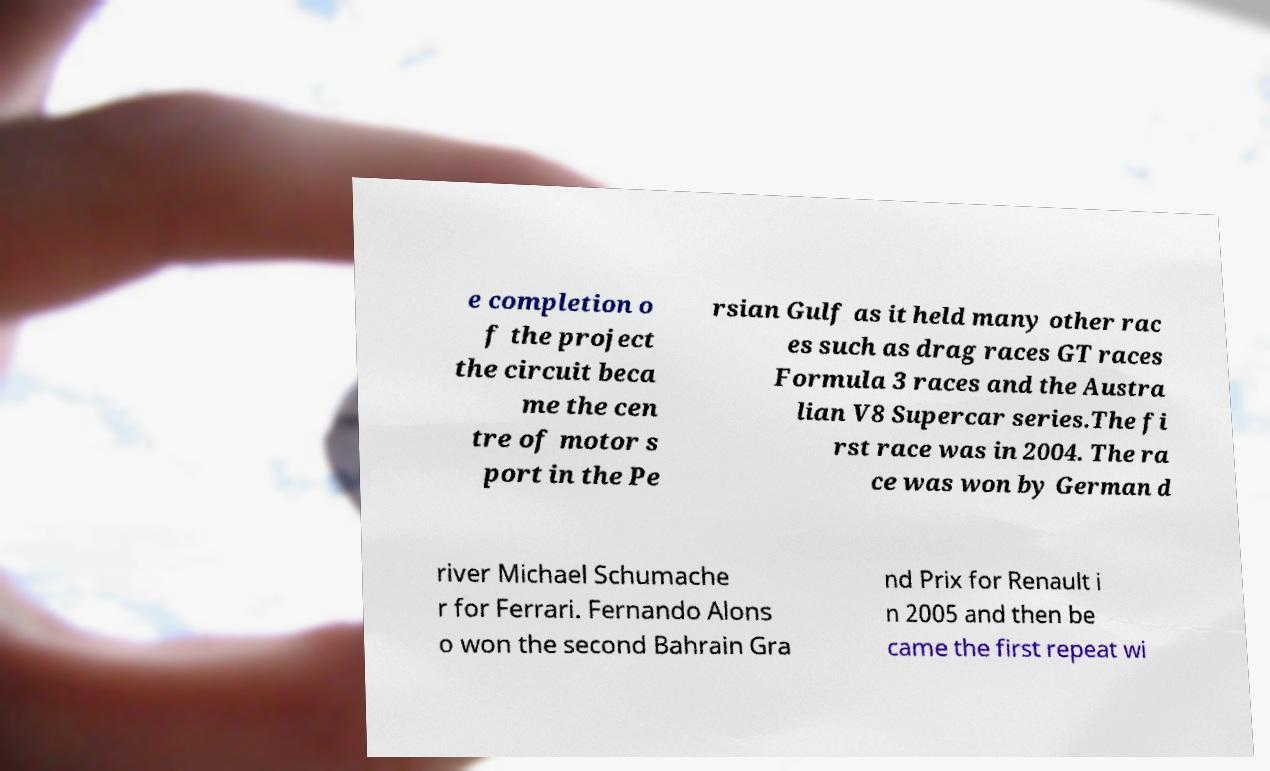Could you extract and type out the text from this image? e completion o f the project the circuit beca me the cen tre of motor s port in the Pe rsian Gulf as it held many other rac es such as drag races GT races Formula 3 races and the Austra lian V8 Supercar series.The fi rst race was in 2004. The ra ce was won by German d river Michael Schumache r for Ferrari. Fernando Alons o won the second Bahrain Gra nd Prix for Renault i n 2005 and then be came the first repeat wi 